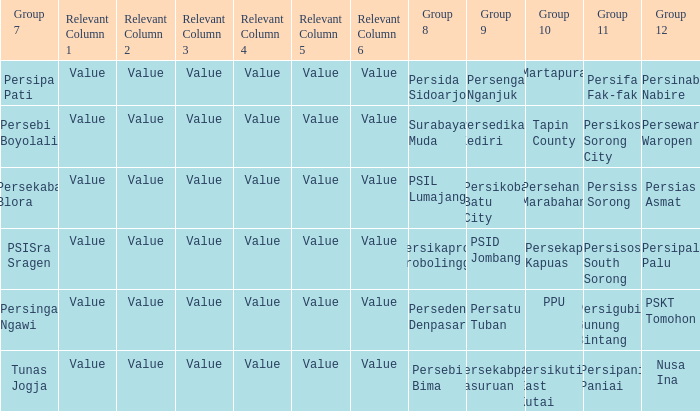When  persikos sorong city played in group 11, who played in group 7? Persebi Boyolali. 